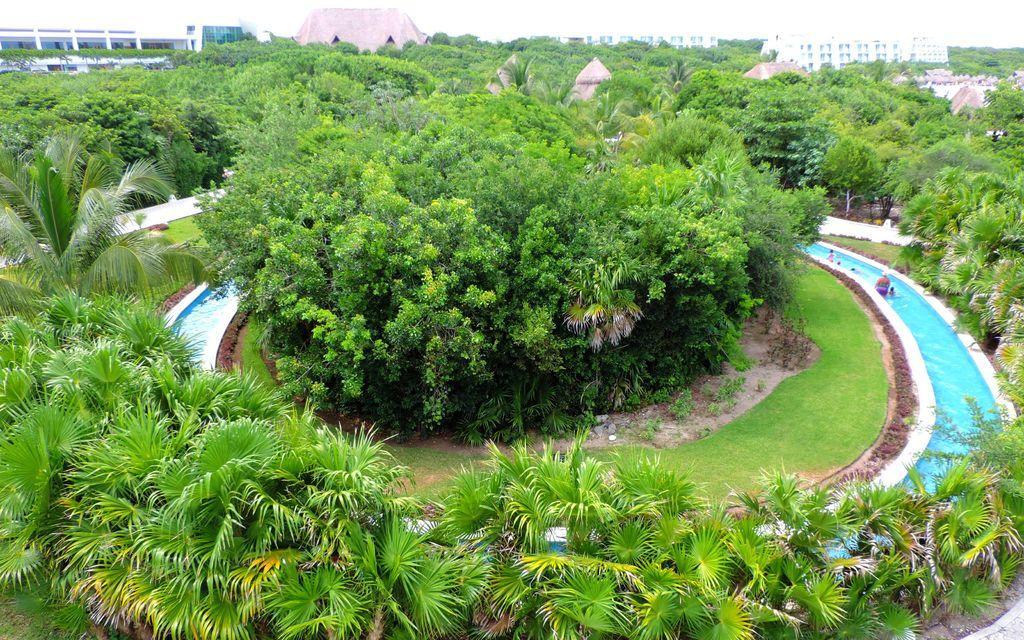Please provide a concise description of this image. In this image I can see few trees which are green in color, water which are blue in color, few people in the water, some grass and the ground. In the background I can see few buildings and the sky. 